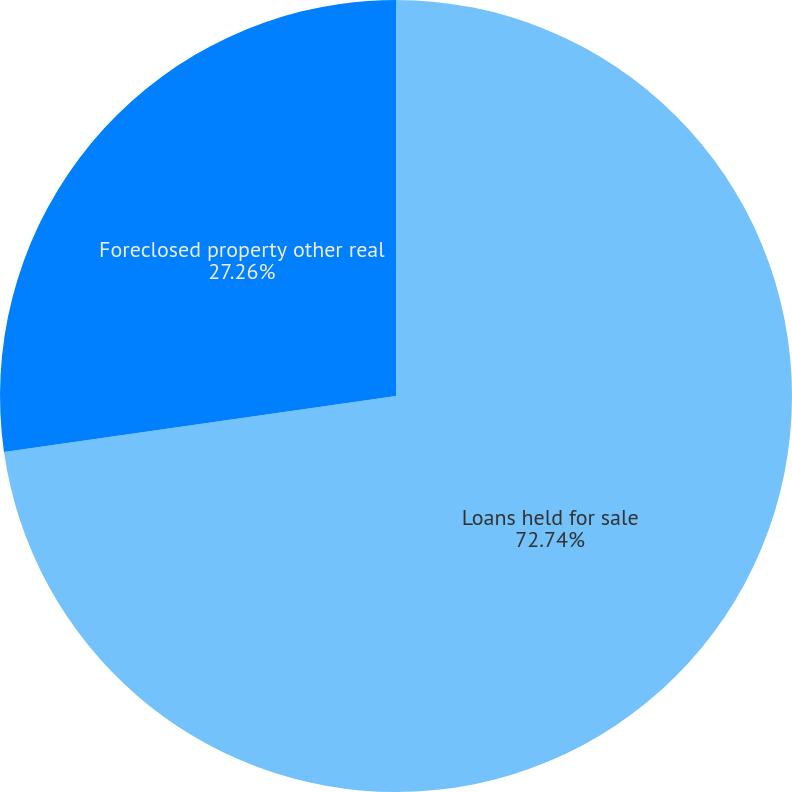<chart> <loc_0><loc_0><loc_500><loc_500><pie_chart><fcel>Loans held for sale<fcel>Foreclosed property other real<nl><fcel>72.74%<fcel>27.26%<nl></chart> 